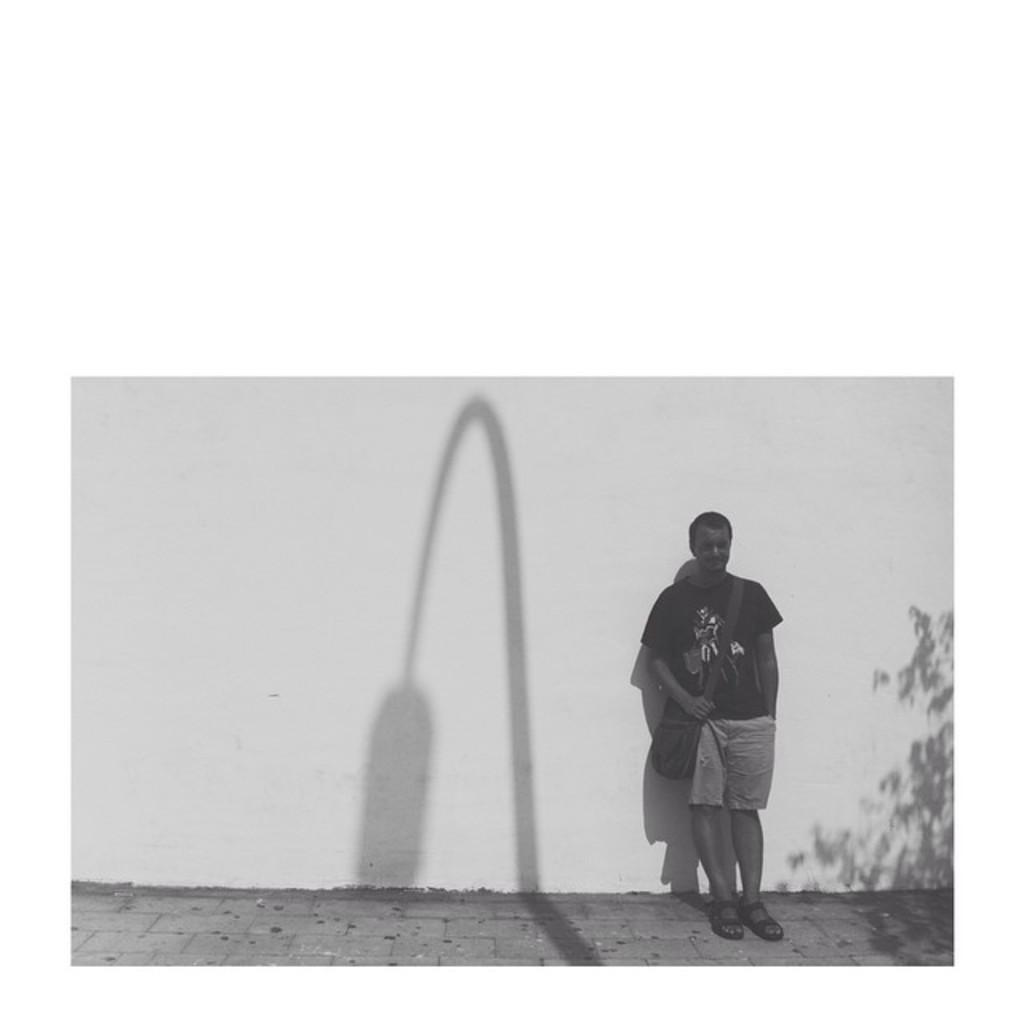What is the main subject of the image? There is a man standing in the image. What is the man holding or carrying in the image? The man is carrying a bag. Can you describe the background of the image? There is a white color wall in the image. What type of ring can be seen on the man's finger in the image? There is no ring visible on the man's finger in the image. What activity is the man participating in with other people in the image? The image only shows a man standing with a bag, and there is no indication of any activity or other people present. 